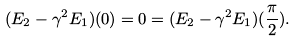Convert formula to latex. <formula><loc_0><loc_0><loc_500><loc_500>( E _ { 2 } - \gamma ^ { 2 } E _ { 1 } ) ( 0 ) = 0 = ( E _ { 2 } - \gamma ^ { 2 } E _ { 1 } ) ( \frac { \pi } { 2 } ) .</formula> 